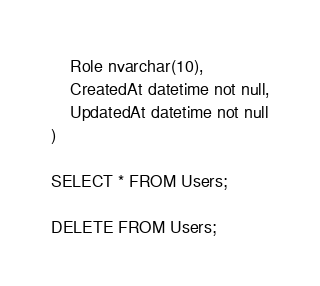<code> <loc_0><loc_0><loc_500><loc_500><_SQL_>    Role nvarchar(10),
	CreatedAt datetime not null,
    UpdatedAt datetime not null
)

SELECT * FROM Users;

DELETE FROM Users;</code> 